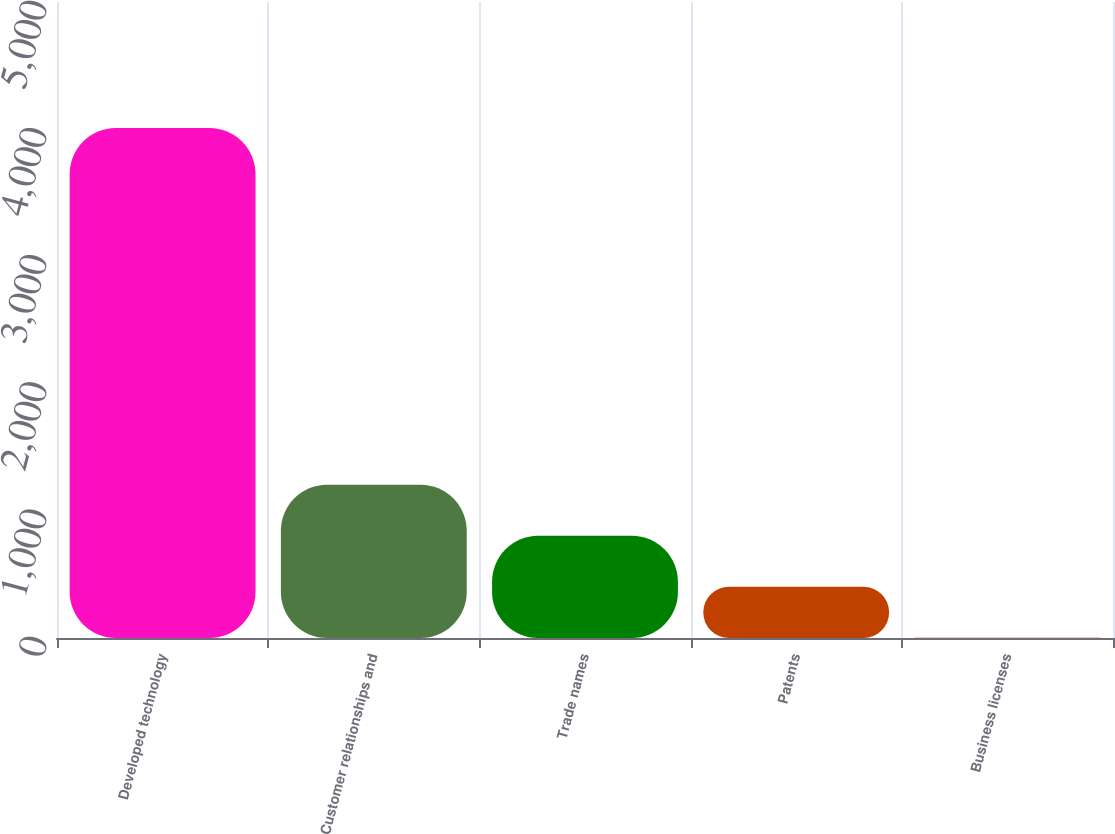<chart> <loc_0><loc_0><loc_500><loc_500><bar_chart><fcel>Developed technology<fcel>Customer relationships and<fcel>Trade names<fcel>Patents<fcel>Business licenses<nl><fcel>4009<fcel>1204.52<fcel>803.88<fcel>403.24<fcel>2.6<nl></chart> 